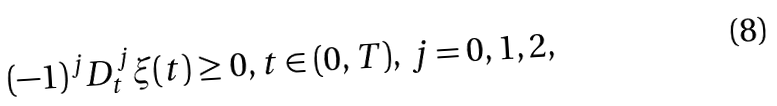Convert formula to latex. <formula><loc_0><loc_0><loc_500><loc_500>( - 1 ) ^ { j } D _ { t } ^ { j } \xi ( t ) \geq 0 , t \in ( 0 , T ) , \, j = 0 , 1 , 2 ,</formula> 